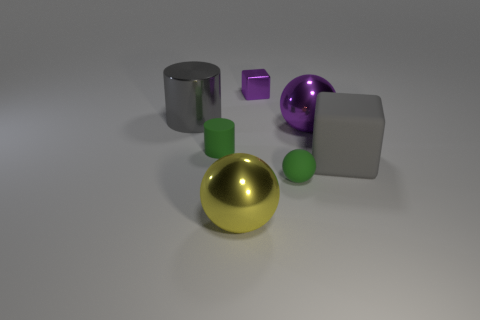Subtract all green matte spheres. How many spheres are left? 2 Add 3 purple cubes. How many objects exist? 10 Subtract all green spheres. How many spheres are left? 2 Subtract all cylinders. How many objects are left? 5 Subtract all tiny brown matte balls. Subtract all small green balls. How many objects are left? 6 Add 5 tiny spheres. How many tiny spheres are left? 6 Add 1 big brown objects. How many big brown objects exist? 1 Subtract 0 brown cubes. How many objects are left? 7 Subtract 1 balls. How many balls are left? 2 Subtract all cyan blocks. Subtract all green cylinders. How many blocks are left? 2 